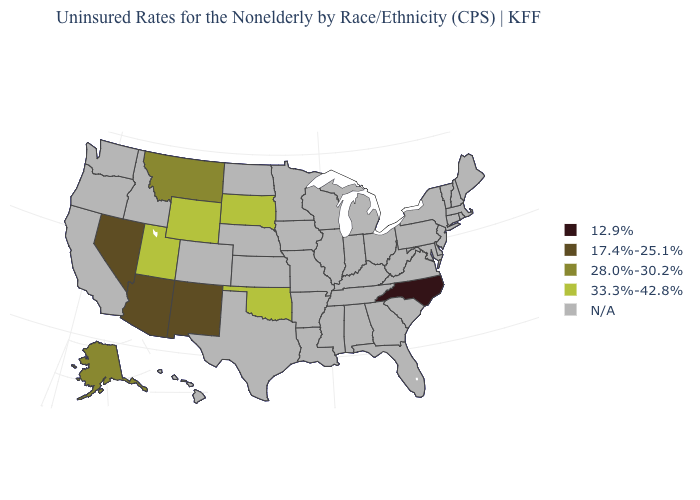Name the states that have a value in the range N/A?
Short answer required. Alabama, Arkansas, California, Colorado, Connecticut, Delaware, Florida, Georgia, Hawaii, Idaho, Illinois, Indiana, Iowa, Kansas, Kentucky, Louisiana, Maine, Maryland, Massachusetts, Michigan, Minnesota, Mississippi, Missouri, Nebraska, New Hampshire, New Jersey, New York, North Dakota, Ohio, Oregon, Pennsylvania, Rhode Island, South Carolina, Tennessee, Texas, Vermont, Virginia, Washington, West Virginia, Wisconsin. What is the value of Minnesota?
Short answer required. N/A. What is the value of Louisiana?
Keep it brief. N/A. Does the map have missing data?
Answer briefly. Yes. Which states have the lowest value in the MidWest?
Answer briefly. South Dakota. What is the value of Nevada?
Quick response, please. 17.4%-25.1%. Name the states that have a value in the range 33.3%-42.8%?
Be succinct. Oklahoma, South Dakota, Utah, Wyoming. Is the legend a continuous bar?
Write a very short answer. No. How many symbols are there in the legend?
Be succinct. 5. Which states hav the highest value in the West?
Answer briefly. Utah, Wyoming. What is the value of New Jersey?
Short answer required. N/A. Name the states that have a value in the range 33.3%-42.8%?
Quick response, please. Oklahoma, South Dakota, Utah, Wyoming. What is the value of Minnesota?
Concise answer only. N/A. 